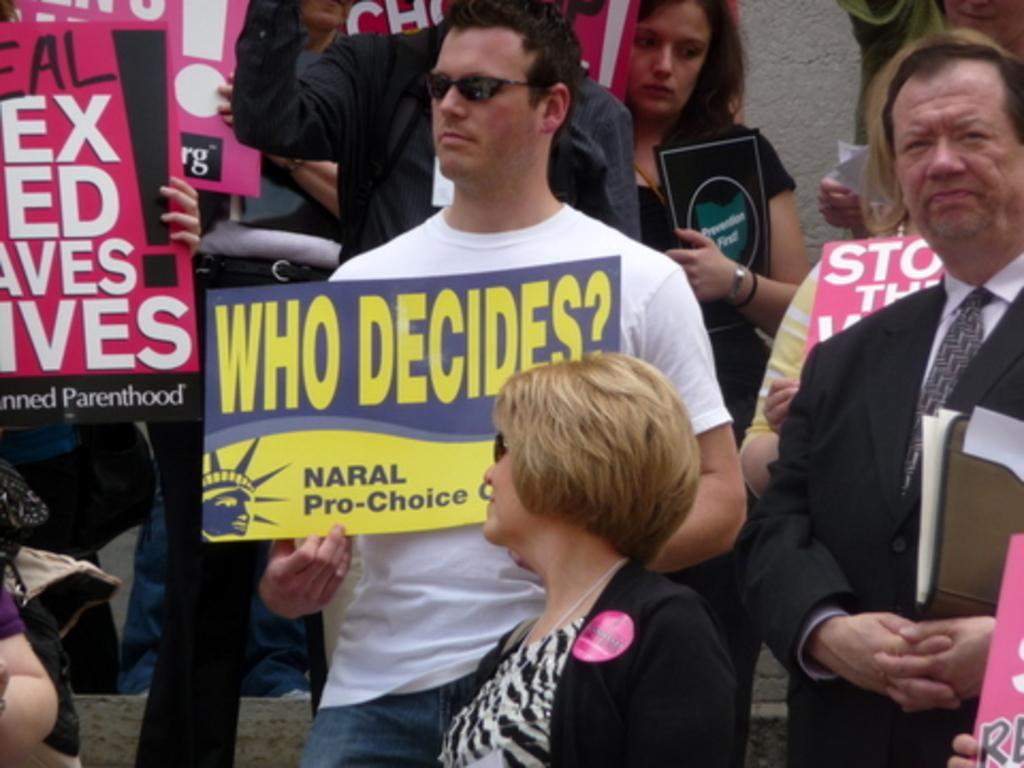What can be seen in the image? There is a group of people in the image. How are the people dressed? The people are wearing different color dresses. What are some of the people holding? Some people are holding boards, and one person is holding a file. What is the weight of the twig in the image? There is no twig present in the image, so it is not possible to determine its weight. 